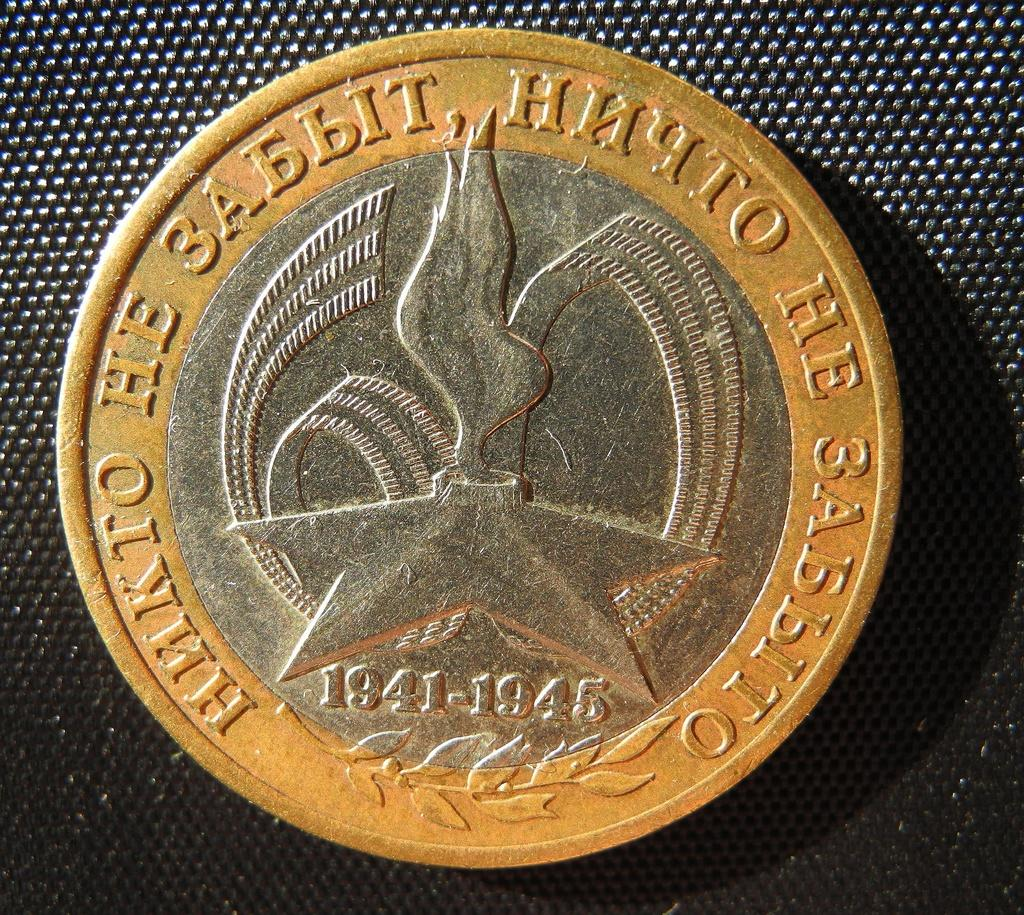<image>
Write a terse but informative summary of the picture. the back side of a russian coin commemorating something that happened in 1941-1945 